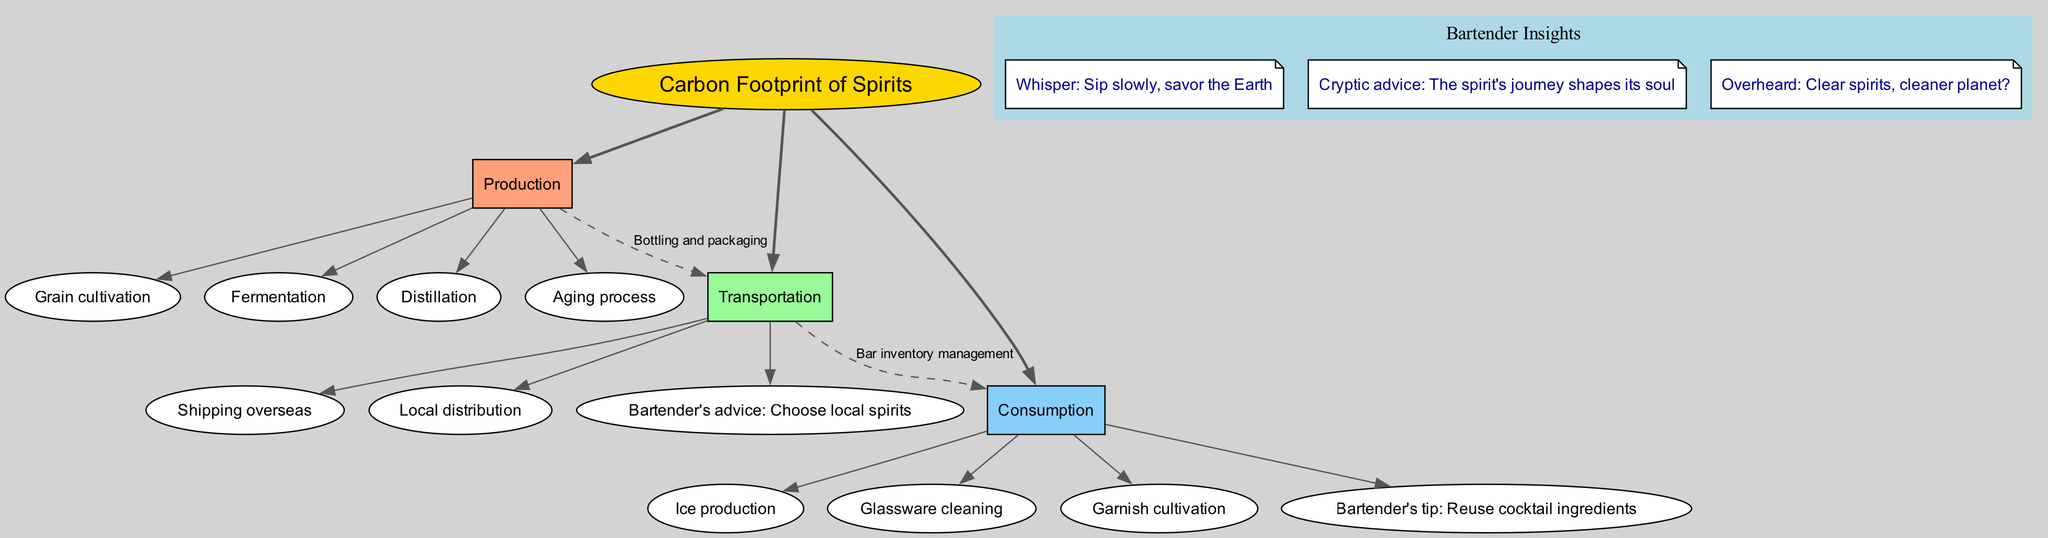What is the central topic of the diagram? The central topic is indicated at the top of the diagram as "Carbon Footprint of Spirits." It is labeled with an ellipse shape.
Answer: Carbon Footprint of Spirits How many main branches are there in the diagram? The diagram shows three main branches extending from the central topic. By visually counting them, we can confirm their presence.
Answer: 3 What are the sub-branches under Transportation? The sub-branches listed under Transportation are "Shipping overseas," "Local distribution," and "Bartender's advice: Choose local spirits." These can be seen emanating from the Transportation branch in the diagram.
Answer: Shipping overseas, Local distribution, Bartender's advice: Choose local spirits Which two branches have a connection? There is a connection from "Production" to "Transportation" and from "Transportation" to "Consumption." These connections are shown as dashed lines in the diagram, indicating a flow between concepts.
Answer: Production and Transportation; Transportation and Consumption What advice does the bartender offer regarding consumption? The bartender's tip listed under the Consumption branch is to "Reuse cocktail ingredients." This insight is part of the suggestions provided in the diagram.
Answer: Reuse cocktail ingredients Explain the significance of the connection labeled "Bottling and packaging." The connection labeled "Bottling and packaging" indicates the relationship between the Production and Transportation branches, showing that what occurs in production, particularly in the bottling stage, directly impacts the transportation process of the spirits. This illustrates the flow of resources and the associated carbon footprint.
Answer: It shows the flow from Production to Transportation What is the insight related to clear spirits? The insight "Clear spirits, cleaner planet?" suggests a potential connection between the type of spirit and its environmental impact. It invites the viewer to think about how the choice of spirits can influence carbon footprints.
Answer: Clear spirits, cleaner planet? How many sub-branches are there in total under all main branches? By examining the sub-branches, we find that there are four under Production, three under Transportation, and four under Consumption, leading to a total of eleven sub-branches.
Answer: 11 